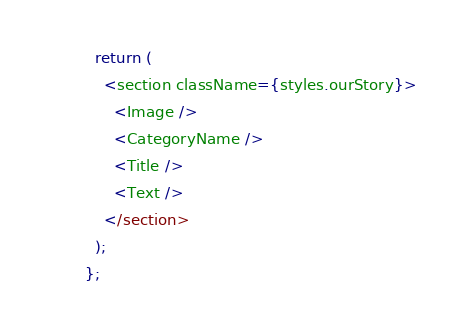Convert code to text. <code><loc_0><loc_0><loc_500><loc_500><_TypeScript_>  return (
    <section className={styles.ourStory}>
      <Image />
      <CategoryName />
      <Title />
      <Text />
    </section>
  );
};
</code> 